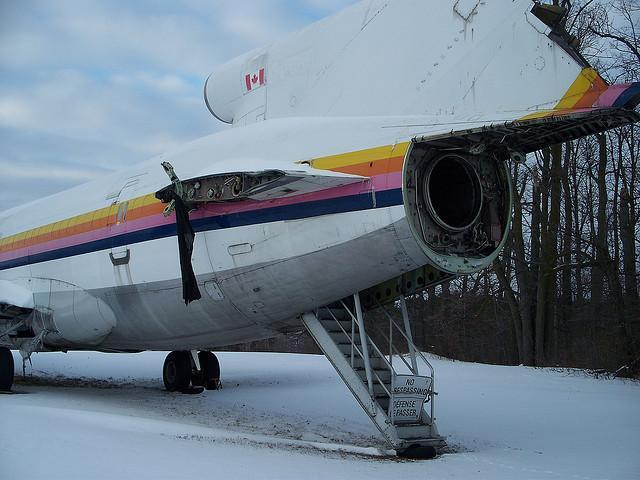How many stripes are on the plane?
Give a very brief answer. 4. How many people are in the pic?
Give a very brief answer. 0. 